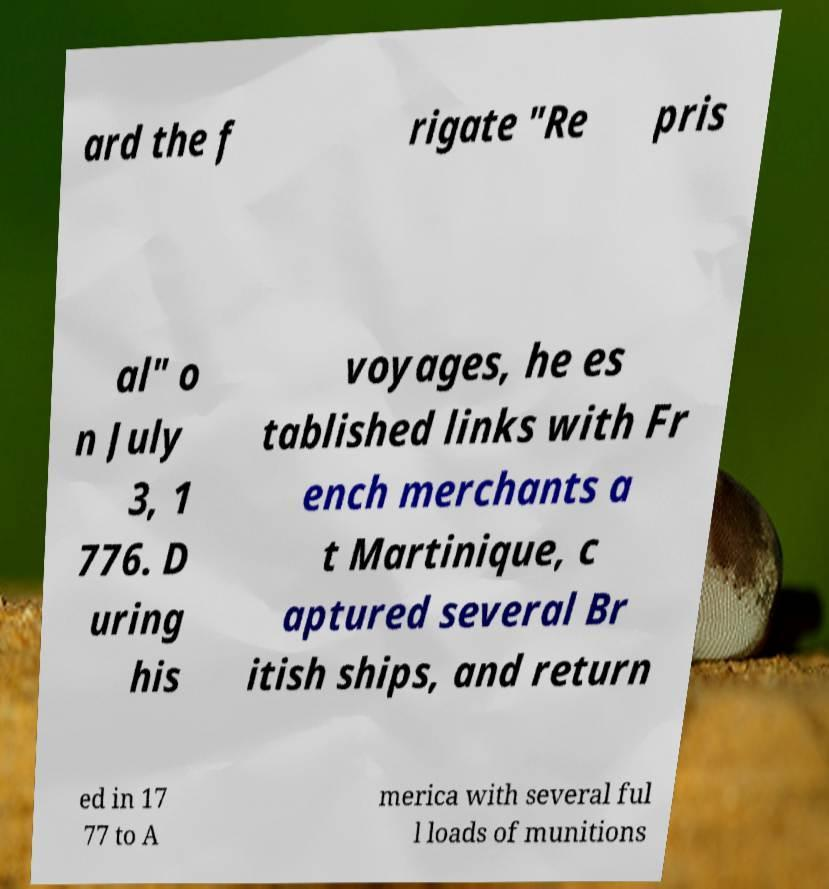There's text embedded in this image that I need extracted. Can you transcribe it verbatim? ard the f rigate "Re pris al" o n July 3, 1 776. D uring his voyages, he es tablished links with Fr ench merchants a t Martinique, c aptured several Br itish ships, and return ed in 17 77 to A merica with several ful l loads of munitions 